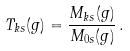Convert formula to latex. <formula><loc_0><loc_0><loc_500><loc_500>T _ { k s } ( g ) = \frac { M _ { k s } ( g ) } { M _ { 0 s } ( g ) } \, .</formula> 